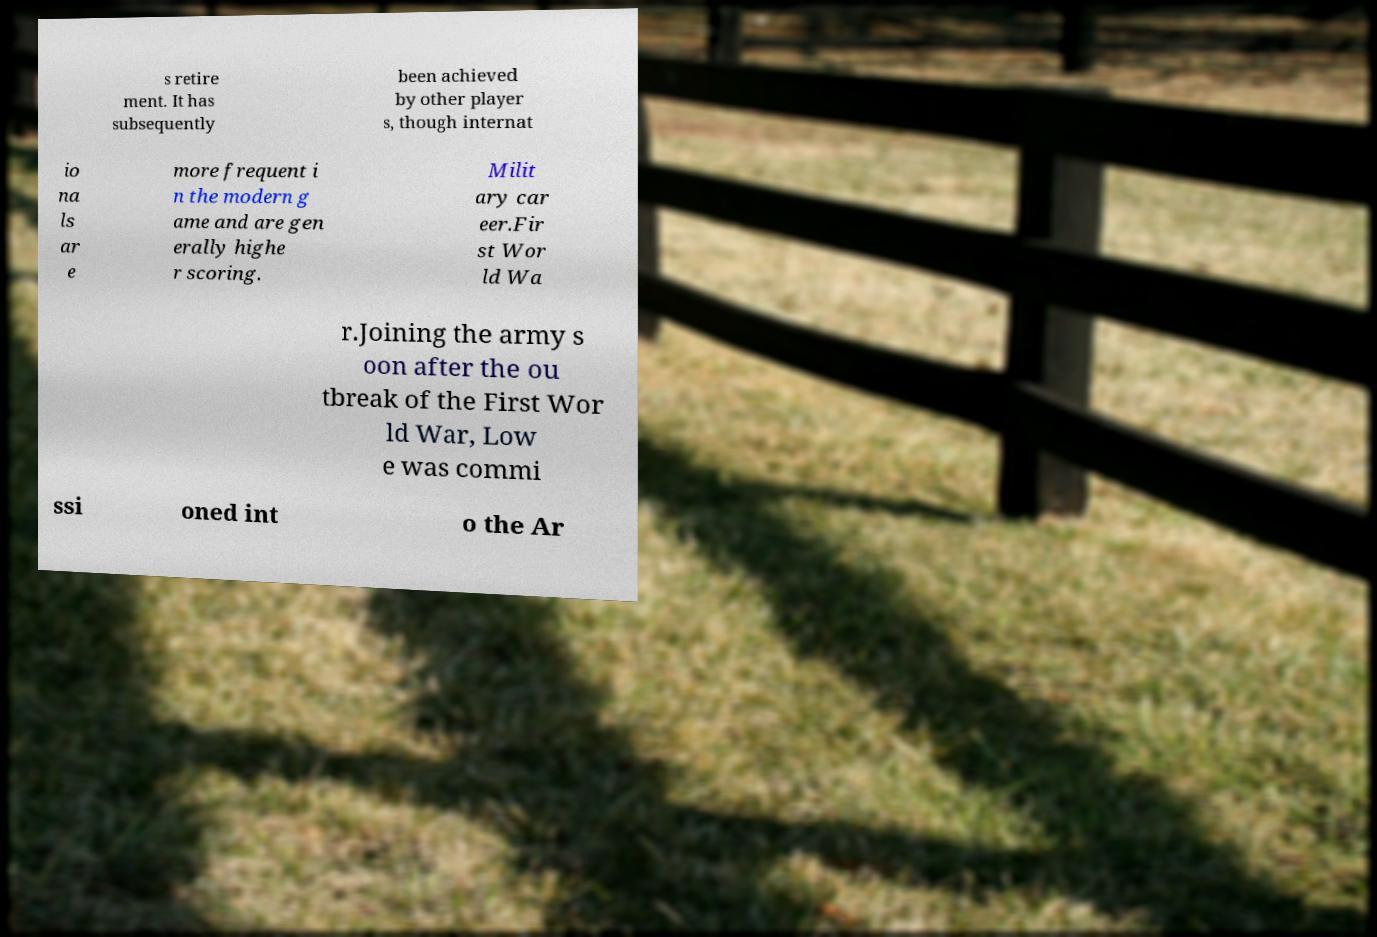Could you assist in decoding the text presented in this image and type it out clearly? s retire ment. It has subsequently been achieved by other player s, though internat io na ls ar e more frequent i n the modern g ame and are gen erally highe r scoring. Milit ary car eer.Fir st Wor ld Wa r.Joining the army s oon after the ou tbreak of the First Wor ld War, Low e was commi ssi oned int o the Ar 